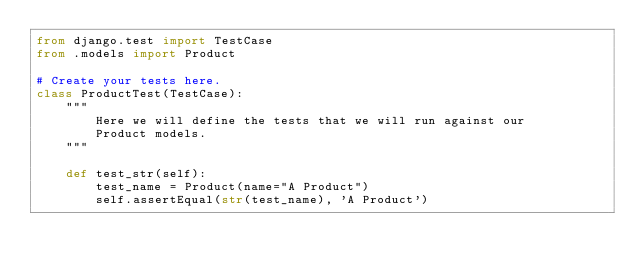Convert code to text. <code><loc_0><loc_0><loc_500><loc_500><_Python_>from django.test import TestCase
from .models import Product

# Create your tests here.
class ProductTest(TestCase):
    """
        Here we will define the tests that we will run against our
        Product models.
    """
    
    def test_str(self):
        test_name = Product(name="A Product")
        self.assertEqual(str(test_name), 'A Product')</code> 